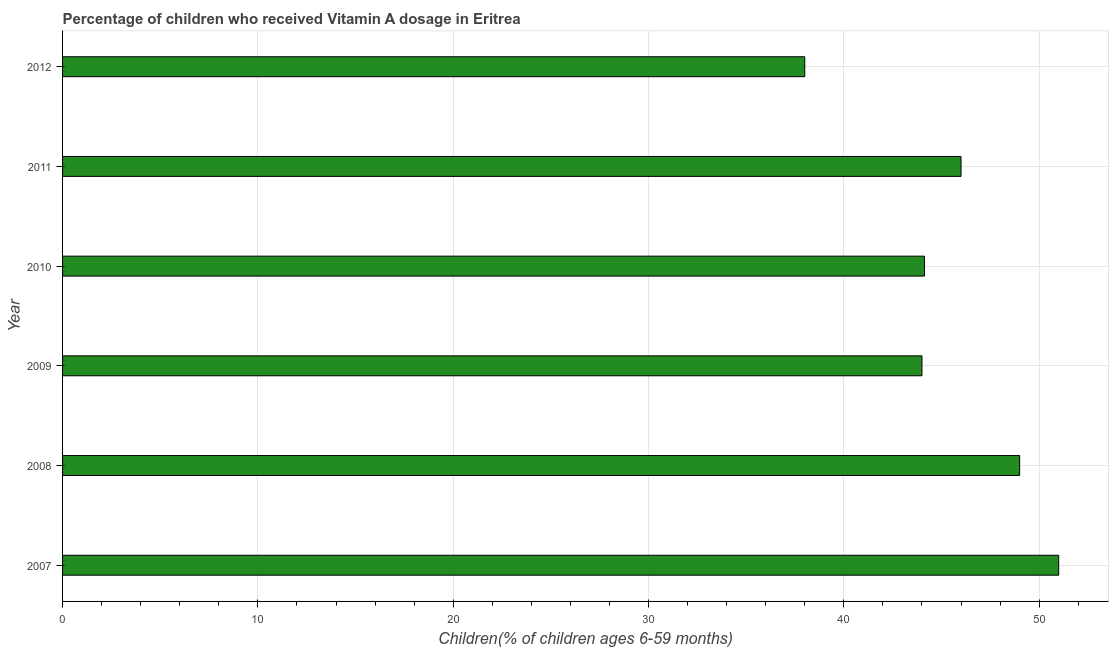Does the graph contain any zero values?
Offer a terse response. No. What is the title of the graph?
Give a very brief answer. Percentage of children who received Vitamin A dosage in Eritrea. What is the label or title of the X-axis?
Give a very brief answer. Children(% of children ages 6-59 months). What is the label or title of the Y-axis?
Offer a terse response. Year. In which year was the vitamin a supplementation coverage rate minimum?
Ensure brevity in your answer.  2012. What is the sum of the vitamin a supplementation coverage rate?
Provide a succinct answer. 272.13. What is the difference between the vitamin a supplementation coverage rate in 2010 and 2011?
Make the answer very short. -1.87. What is the average vitamin a supplementation coverage rate per year?
Keep it short and to the point. 45.35. What is the median vitamin a supplementation coverage rate?
Provide a succinct answer. 45.06. In how many years, is the vitamin a supplementation coverage rate greater than 20 %?
Your answer should be compact. 6. Do a majority of the years between 2008 and 2009 (inclusive) have vitamin a supplementation coverage rate greater than 50 %?
Your answer should be compact. No. What is the ratio of the vitamin a supplementation coverage rate in 2007 to that in 2012?
Your answer should be compact. 1.34. Is the difference between the vitamin a supplementation coverage rate in 2009 and 2011 greater than the difference between any two years?
Offer a very short reply. No. What is the difference between the highest and the lowest vitamin a supplementation coverage rate?
Provide a succinct answer. 13. In how many years, is the vitamin a supplementation coverage rate greater than the average vitamin a supplementation coverage rate taken over all years?
Offer a very short reply. 3. How many bars are there?
Keep it short and to the point. 6. Are all the bars in the graph horizontal?
Provide a short and direct response. Yes. What is the Children(% of children ages 6-59 months) of 2007?
Give a very brief answer. 51. What is the Children(% of children ages 6-59 months) of 2009?
Offer a terse response. 44. What is the Children(% of children ages 6-59 months) of 2010?
Give a very brief answer. 44.13. What is the Children(% of children ages 6-59 months) in 2011?
Ensure brevity in your answer.  46. What is the Children(% of children ages 6-59 months) in 2012?
Provide a succinct answer. 38. What is the difference between the Children(% of children ages 6-59 months) in 2007 and 2008?
Your answer should be very brief. 2. What is the difference between the Children(% of children ages 6-59 months) in 2007 and 2009?
Provide a succinct answer. 7. What is the difference between the Children(% of children ages 6-59 months) in 2007 and 2010?
Provide a short and direct response. 6.87. What is the difference between the Children(% of children ages 6-59 months) in 2007 and 2011?
Give a very brief answer. 5. What is the difference between the Children(% of children ages 6-59 months) in 2008 and 2009?
Offer a very short reply. 5. What is the difference between the Children(% of children ages 6-59 months) in 2008 and 2010?
Keep it short and to the point. 4.87. What is the difference between the Children(% of children ages 6-59 months) in 2008 and 2011?
Ensure brevity in your answer.  3. What is the difference between the Children(% of children ages 6-59 months) in 2008 and 2012?
Give a very brief answer. 11. What is the difference between the Children(% of children ages 6-59 months) in 2009 and 2010?
Provide a short and direct response. -0.13. What is the difference between the Children(% of children ages 6-59 months) in 2009 and 2012?
Your answer should be very brief. 6. What is the difference between the Children(% of children ages 6-59 months) in 2010 and 2011?
Keep it short and to the point. -1.87. What is the difference between the Children(% of children ages 6-59 months) in 2010 and 2012?
Offer a very short reply. 6.13. What is the difference between the Children(% of children ages 6-59 months) in 2011 and 2012?
Give a very brief answer. 8. What is the ratio of the Children(% of children ages 6-59 months) in 2007 to that in 2008?
Your response must be concise. 1.04. What is the ratio of the Children(% of children ages 6-59 months) in 2007 to that in 2009?
Provide a short and direct response. 1.16. What is the ratio of the Children(% of children ages 6-59 months) in 2007 to that in 2010?
Give a very brief answer. 1.16. What is the ratio of the Children(% of children ages 6-59 months) in 2007 to that in 2011?
Keep it short and to the point. 1.11. What is the ratio of the Children(% of children ages 6-59 months) in 2007 to that in 2012?
Provide a succinct answer. 1.34. What is the ratio of the Children(% of children ages 6-59 months) in 2008 to that in 2009?
Provide a succinct answer. 1.11. What is the ratio of the Children(% of children ages 6-59 months) in 2008 to that in 2010?
Keep it short and to the point. 1.11. What is the ratio of the Children(% of children ages 6-59 months) in 2008 to that in 2011?
Keep it short and to the point. 1.06. What is the ratio of the Children(% of children ages 6-59 months) in 2008 to that in 2012?
Your answer should be very brief. 1.29. What is the ratio of the Children(% of children ages 6-59 months) in 2009 to that in 2010?
Make the answer very short. 1. What is the ratio of the Children(% of children ages 6-59 months) in 2009 to that in 2011?
Ensure brevity in your answer.  0.96. What is the ratio of the Children(% of children ages 6-59 months) in 2009 to that in 2012?
Offer a terse response. 1.16. What is the ratio of the Children(% of children ages 6-59 months) in 2010 to that in 2012?
Your response must be concise. 1.16. What is the ratio of the Children(% of children ages 6-59 months) in 2011 to that in 2012?
Offer a very short reply. 1.21. 